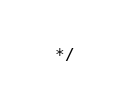<code> <loc_0><loc_0><loc_500><loc_500><_JavaScript_> */
</code> 